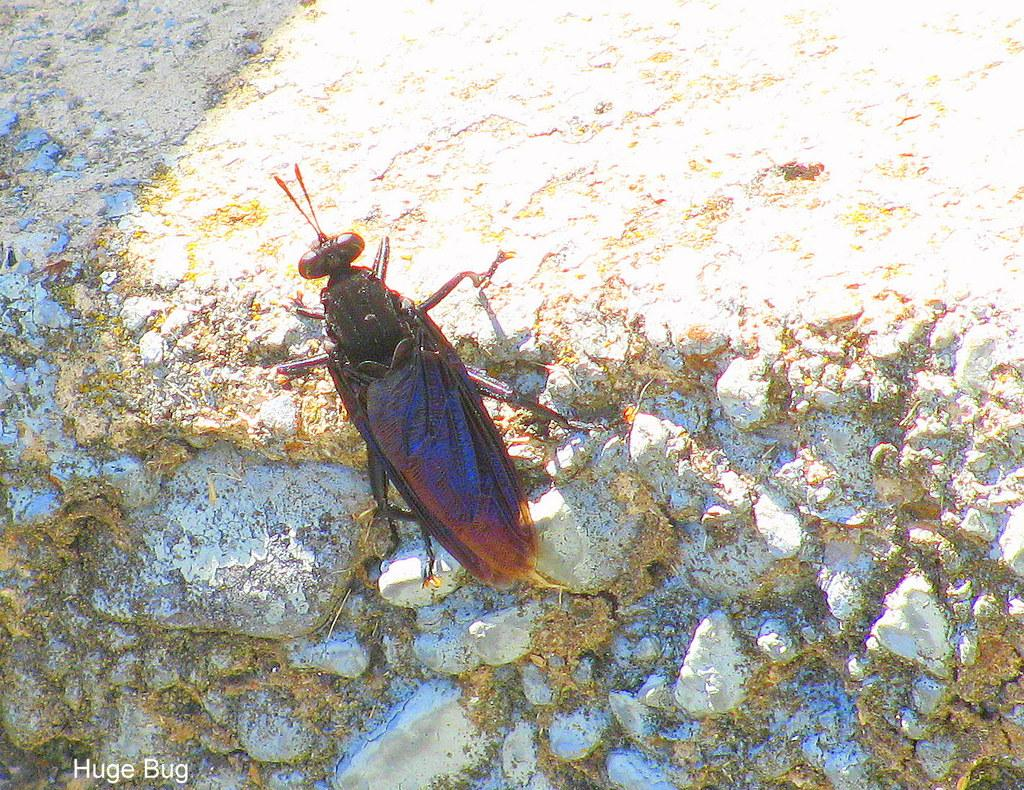What is present in the image? There is an insect in the image. Where is the insect located? The insect is on a rock. What colors can be seen on the insect? The insect has black and brown coloring. How does the insect adjust the volume of the wilderness in the image? There is no indication of the insect adjusting the volume of the wilderness in the image, as insects do not have the ability to control sound levels. 